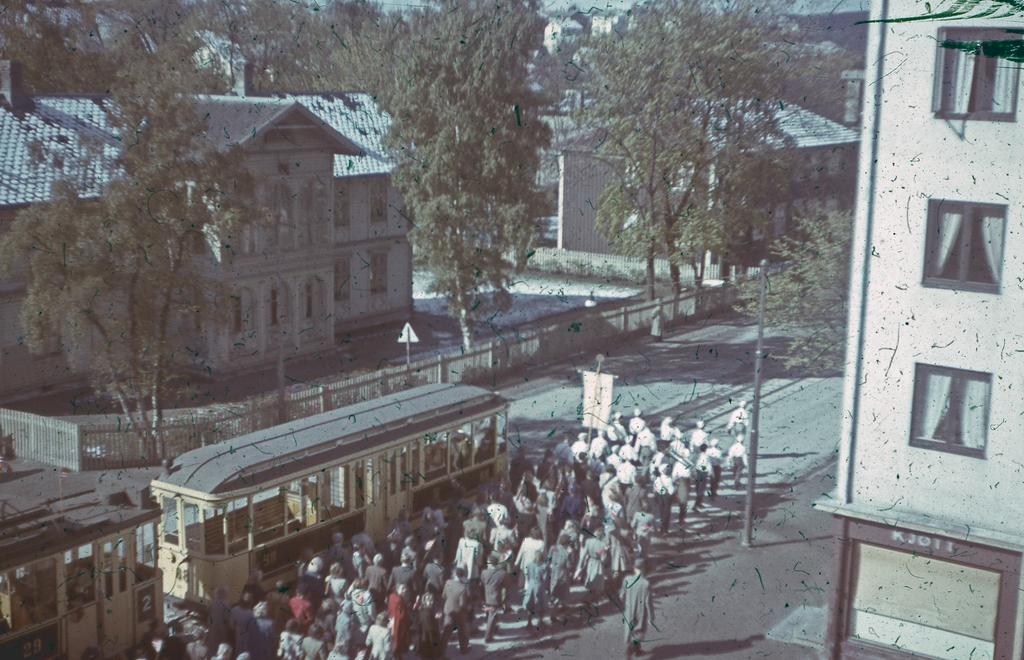What is happening with the group of people in the image? There is a crowd of people walking on the road. What else can be seen in the image besides the people? There is a vehicle and trees visible on both sides of the road. What type of structures are present on both sides of the road? Buildings are present on both sides of the road. Can you hear the bat learning to fly in the image? There is no bat or indication of learning in the image; it features a crowd of people walking on the road, a vehicle, trees, and buildings. 